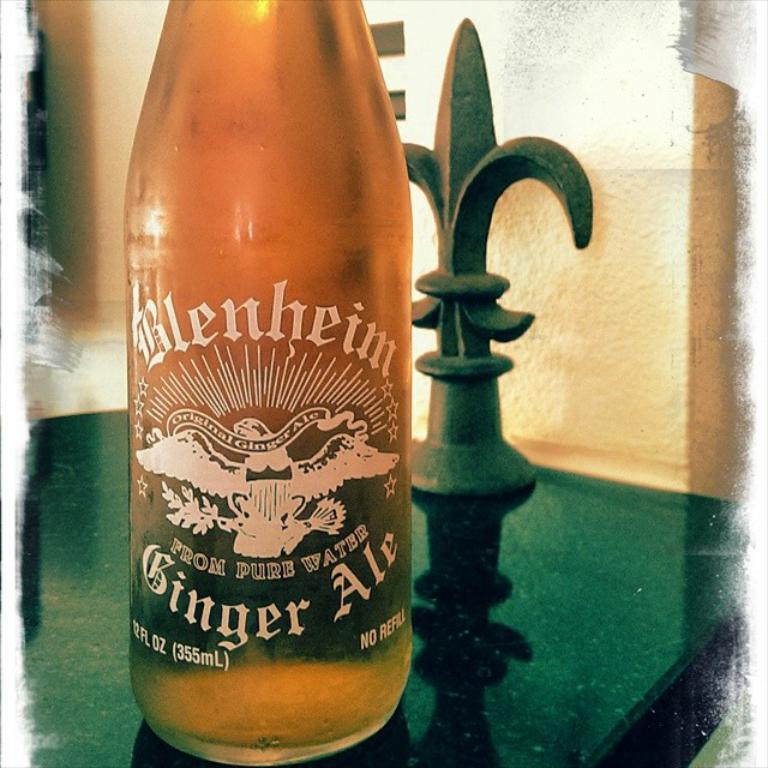<image>
Offer a succinct explanation of the picture presented. A bottle of amber color Blenheim Ginger Ale sitting on a dark counter top. 